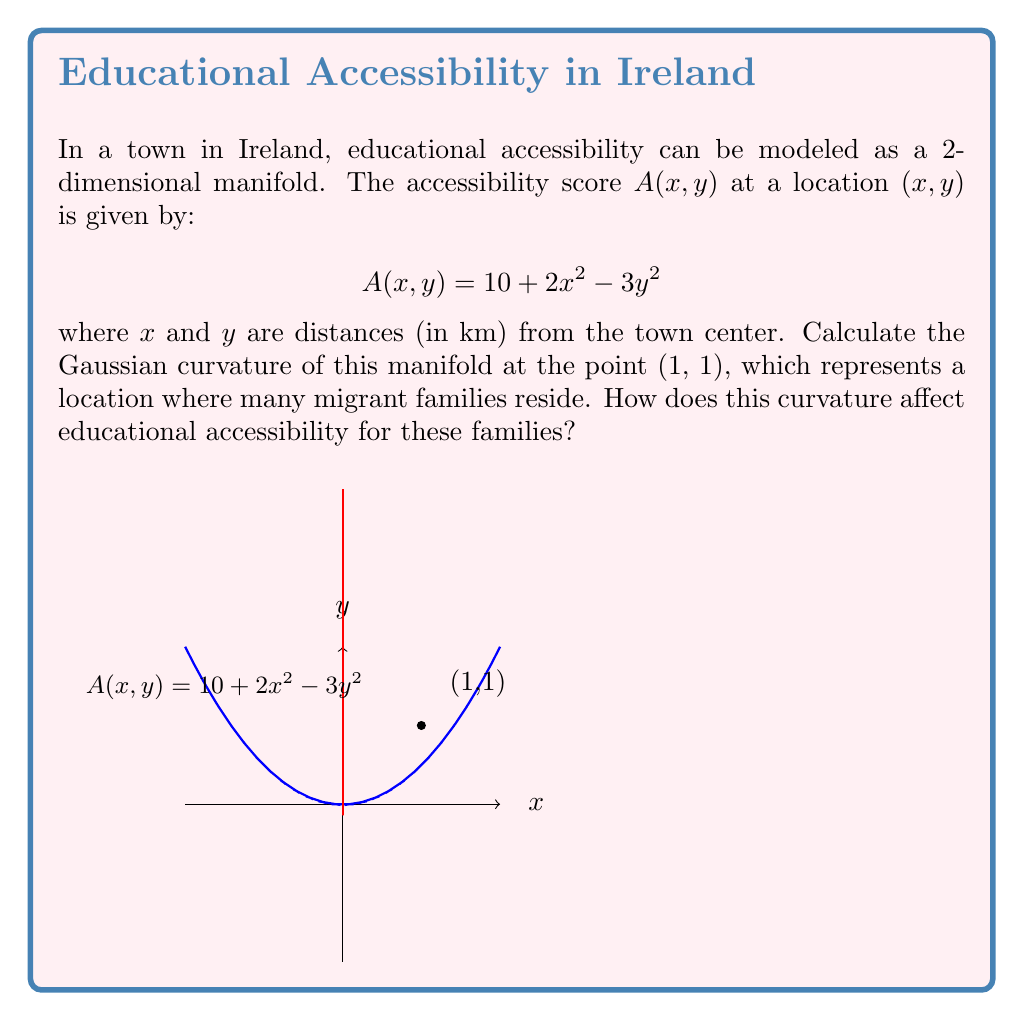Solve this math problem. To find the Gaussian curvature of the 2D manifold, we need to follow these steps:

1) The manifold is given by the function $z = A(x,y) = 10 + 2x^2 - 3y^2$

2) Calculate the first and second partial derivatives:
   $A_x = 4x$, $A_y = -6y$
   $A_{xx} = 4$, $A_{yy} = -6$, $A_{xy} = A_{yx} = 0$

3) The Gaussian curvature K is given by:

   $$K = \frac{A_{xx}A_{yy} - A_{xy}^2}{(1 + A_x^2 + A_y^2)^2}$$

4) Substitute the values at (1,1):
   $A_x = 4$, $A_y = -6$
   $A_{xx} = 4$, $A_{yy} = -6$, $A_{xy} = 0$

5) Calculate K:
   $$K = \frac{4 \cdot (-6) - 0^2}{(1 + 4^2 + (-6)^2)^2} = \frac{-24}{(1 + 16 + 36)^2} = \frac{-24}{53^2} \approx -0.0085$$

6) Interpretation: The negative curvature indicates that the manifold is saddle-shaped at (1,1). This means that educational accessibility increases in one direction (likely towards the town center) but decreases in the perpendicular direction. For migrant families at this location, this suggests that while some educational resources may be readily accessible, others might be more challenging to reach, highlighting the need for targeted support in navigating the local education system.
Answer: $K = -\frac{24}{53^2} \approx -0.0085$ 